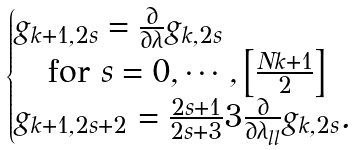Convert formula to latex. <formula><loc_0><loc_0><loc_500><loc_500>\begin{cases} g _ { k + 1 , 2 s } = \frac { \partial } { \partial \lambda } g _ { k , 2 s } \\ \quad \text {for } s = 0 , \cdots , \left [ \frac { N k + 1 } { 2 } \right ] \\ g _ { k + 1 , 2 s + 2 } = \frac { 2 s + 1 } { 2 s + 3 } 3 \frac { \partial } { \partial \lambda _ { l l } } g _ { k , 2 s } . \end{cases}</formula> 